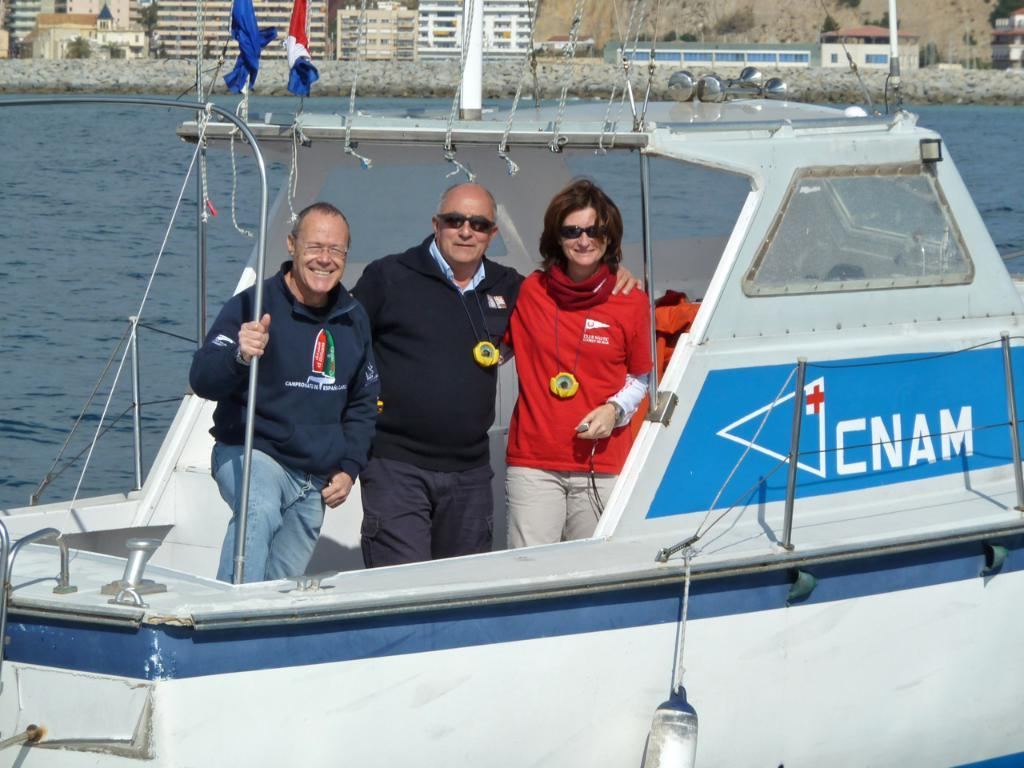<image>
Relay a brief, clear account of the picture shown. Three people that are standing in a boat labeled CNAM. 